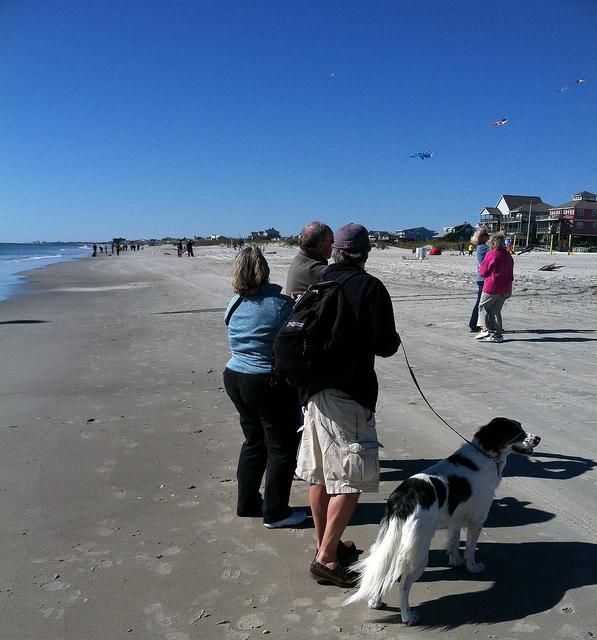What does the dog have?
Concise answer only. Leash. Is this dog fixated on the same thing as the owners?
Write a very short answer. No. What is the girl looking at?
Short answer required. Kites. What breed is the dog?
Give a very brief answer. Spaniel. Is the dog wearing a sweater?
Write a very short answer. No. How many people are on the beach?
Write a very short answer. 5. Is the dog playing?
Concise answer only. No. Are there shoes on the person's feet?
Short answer required. Yes. 